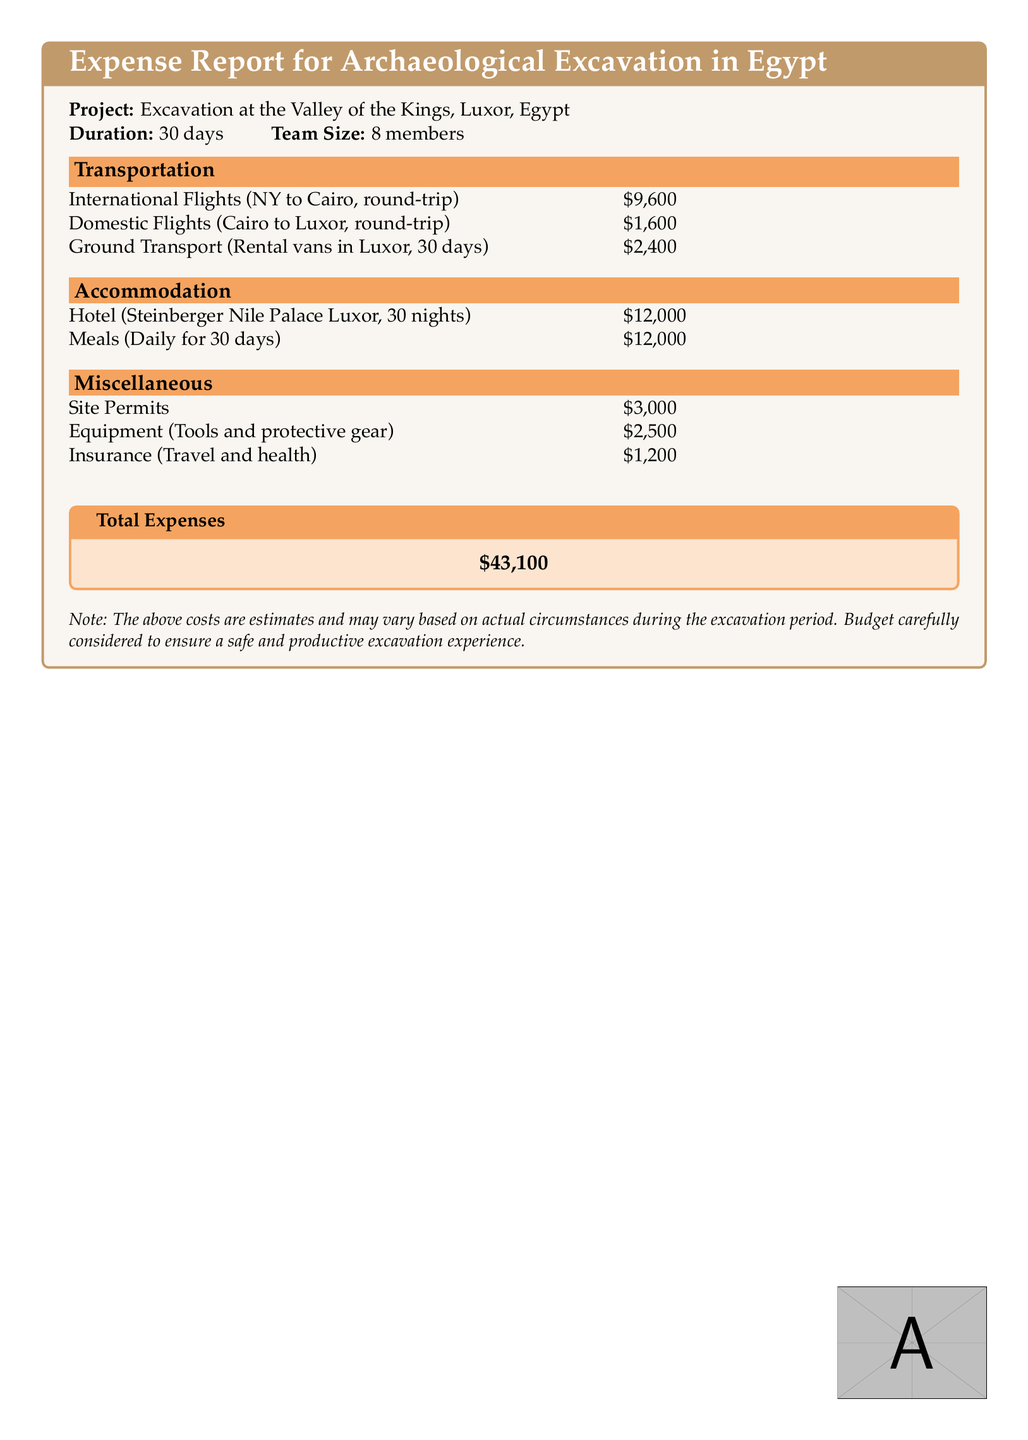What is the project location? The project location is specifically mentioned in the heading of the report as the Valley of the Kings, Luxor, Egypt.
Answer: Valley of the Kings, Luxor, Egypt How many team members are involved? The team size is listed in the introduction section of the report as 8 members.
Answer: 8 members What is the total accommodation cost? The accommodation costs consist of the hotel stay and meals, which total $12,000 + $12,000 = $24,000.
Answer: $24,000 What is the cost of international flights? The cost of international flights, which is mentioned under transportation, is $9,600.
Answer: $9,600 How long is the excavation duration? The duration of the excavation project is clearly stated in the introduction section as 30 days.
Answer: 30 days What is the total expense reported? The total expenses are summarized at the end of the document as $43,100.
Answer: $43,100 What miscellaneous cost is higher: site permits or insurance? The miscellaneous costs for site permits and insurance are $3,000 and $1,200 respectively, indicating site permits are higher.
Answer: Site Permits How many nights was the hotel booked? The hotel booking duration is specified to be for 30 nights in the accommodation section.
Answer: 30 nights What is the cost of ground transport? The expense for ground transport is shown in the document as $2,400.
Answer: $2,400 